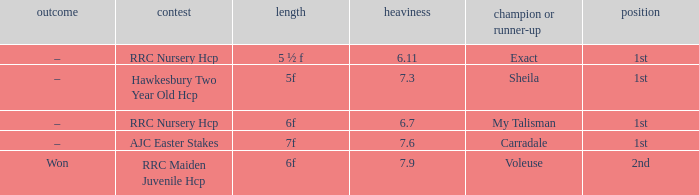What was the race when the winner of 2nd was Voleuse? RRC Maiden Juvenile Hcp. 